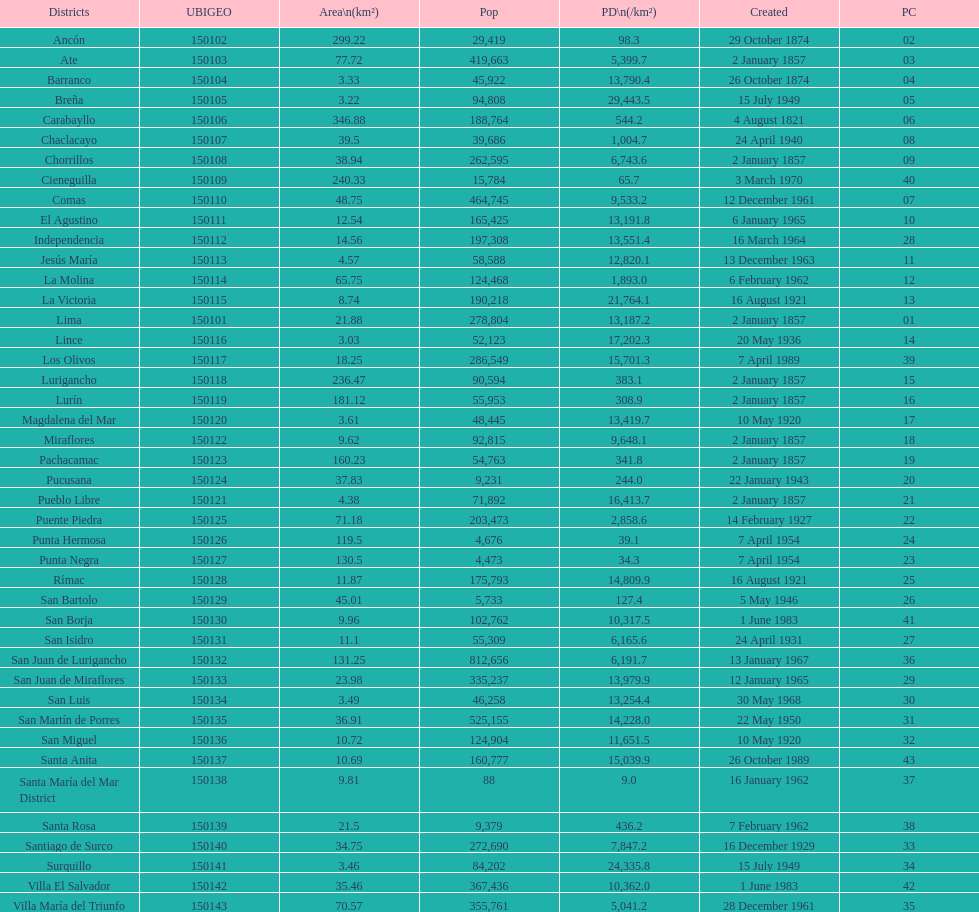What is the total number of districts of lima? 43. 